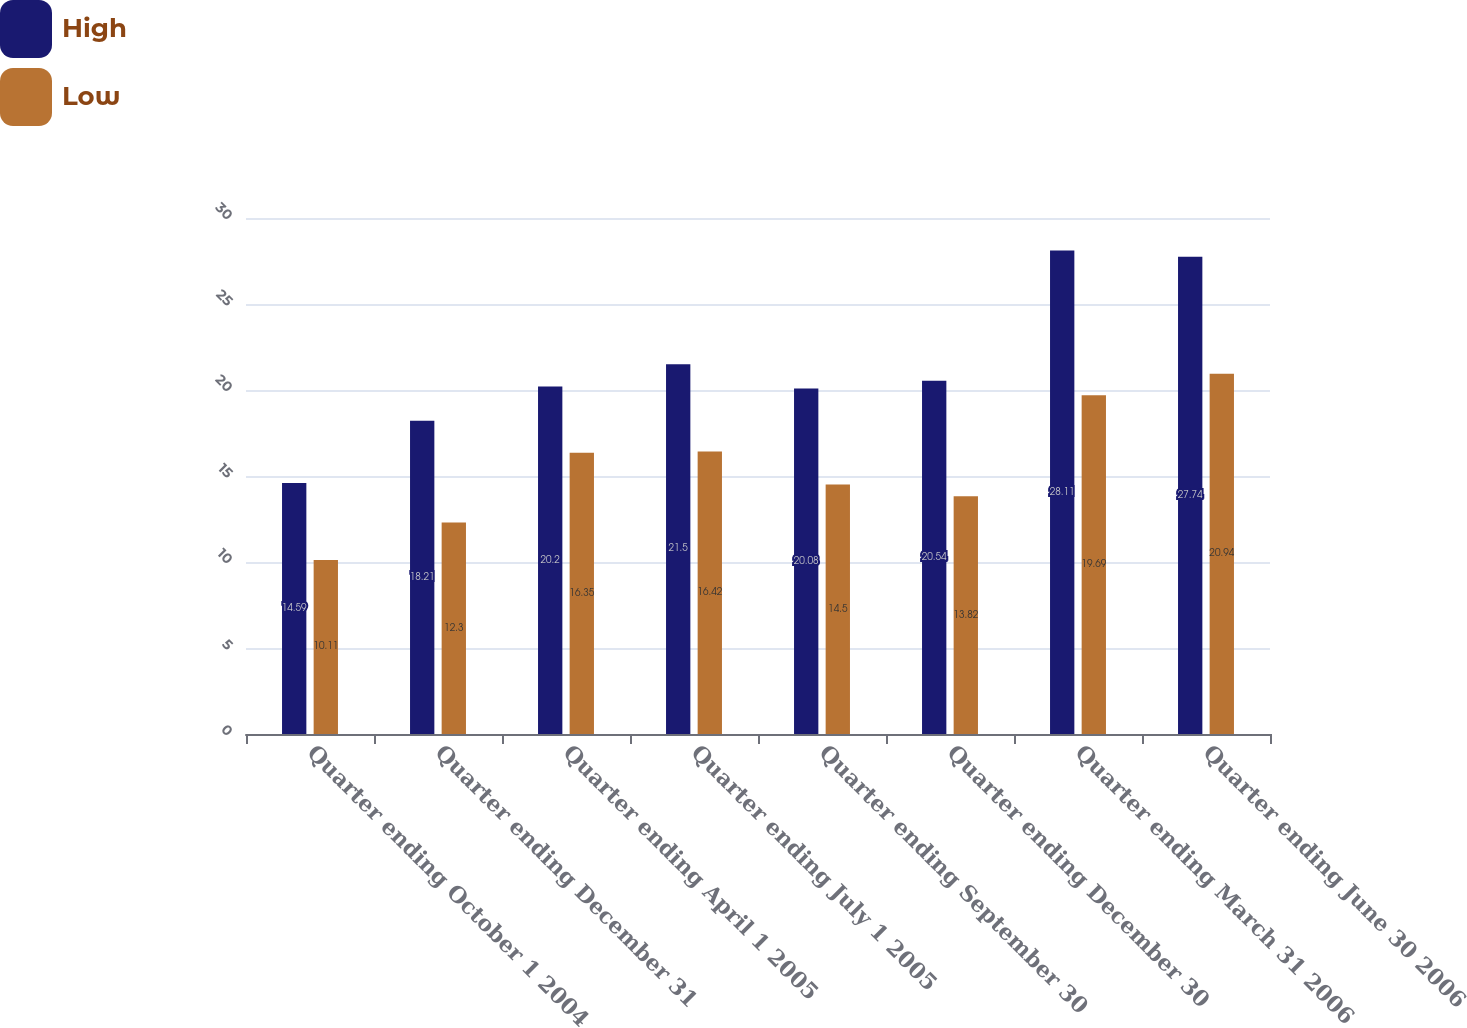Convert chart. <chart><loc_0><loc_0><loc_500><loc_500><stacked_bar_chart><ecel><fcel>Quarter ending October 1 2004<fcel>Quarter ending December 31<fcel>Quarter ending April 1 2005<fcel>Quarter ending July 1 2005<fcel>Quarter ending September 30<fcel>Quarter ending December 30<fcel>Quarter ending March 31 2006<fcel>Quarter ending June 30 2006<nl><fcel>High<fcel>14.59<fcel>18.21<fcel>20.2<fcel>21.5<fcel>20.08<fcel>20.54<fcel>28.11<fcel>27.74<nl><fcel>Low<fcel>10.11<fcel>12.3<fcel>16.35<fcel>16.42<fcel>14.5<fcel>13.82<fcel>19.69<fcel>20.94<nl></chart> 